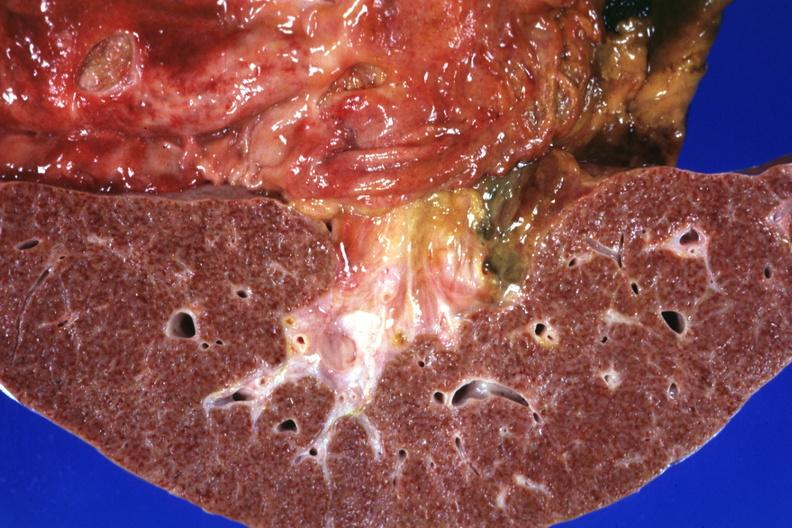does normal ovary show gastric and duodenal ulcers?
Answer the question using a single word or phrase. No 